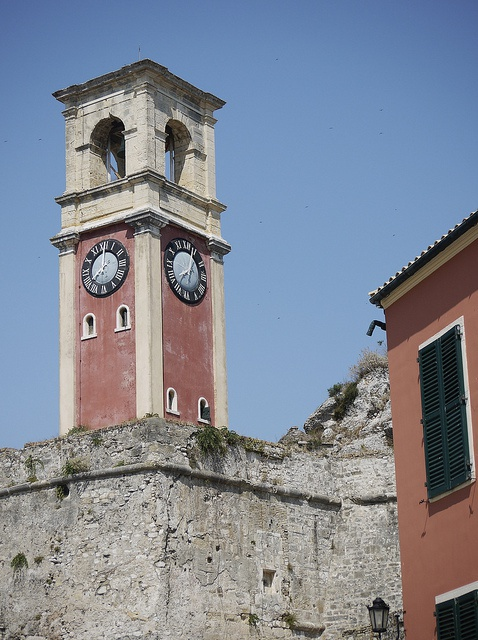Describe the objects in this image and their specific colors. I can see clock in blue, black, gray, darkgray, and lightgray tones and clock in blue, black, darkgray, gray, and lightgray tones in this image. 